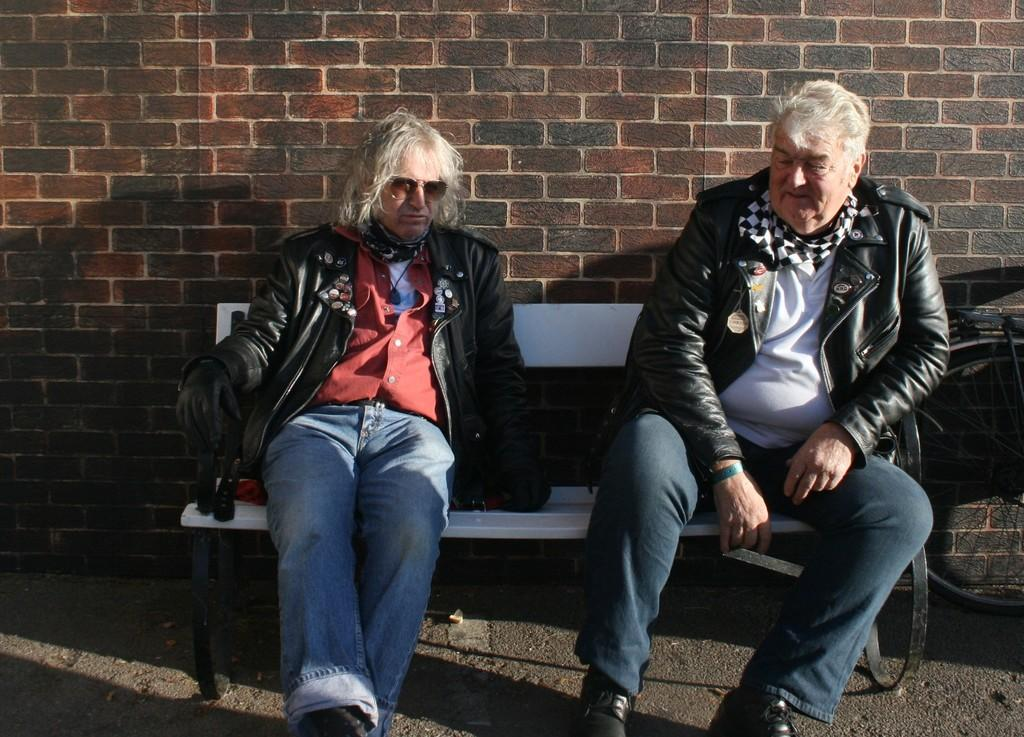How many people are sitting on the bench in the image? There are two people sitting on a bench in the image. What is located at the bottom of the image? There is a walkway at the bottom of the image. What can be seen on the right side of the image? There is a wheel visible on the right side of the image. What type of structure is in the background of the image? There is a brick wall in the background of the image. What time of day is it in the image, based on the hour shown on the car's clock? There is no car present in the image, so we cannot determine the time of day based on a car's clock. 